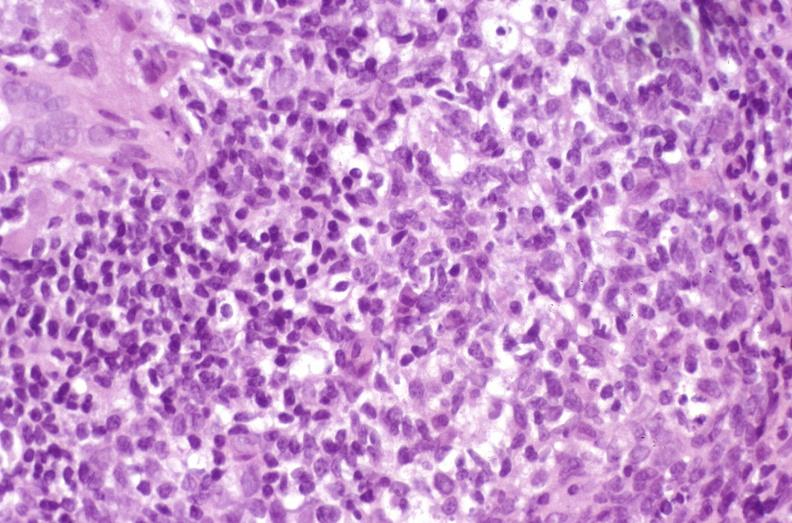what does this image show?
Answer the question using a single word or phrase. Recurrent hepatitis c virus 